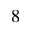Convert formula to latex. <formula><loc_0><loc_0><loc_500><loc_500>_ { 8 }</formula> 